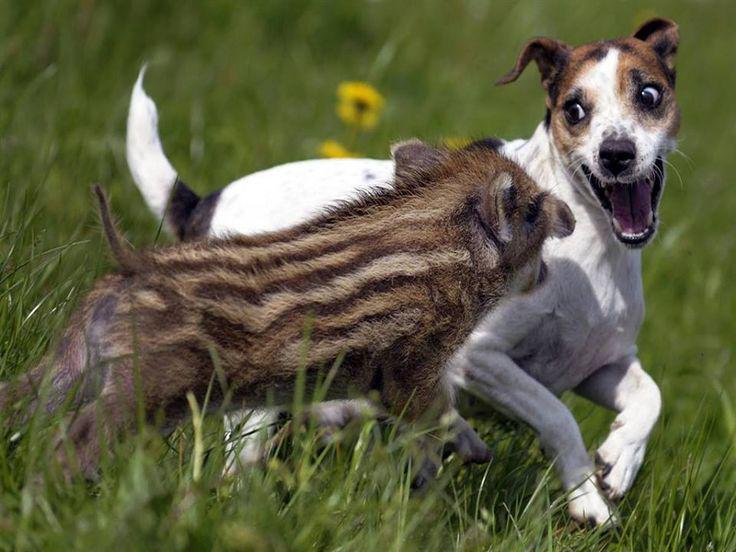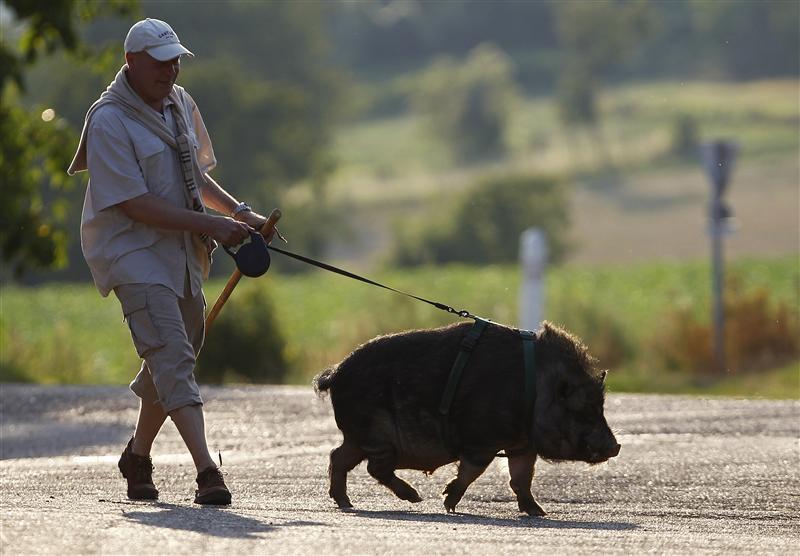The first image is the image on the left, the second image is the image on the right. Given the left and right images, does the statement "One pig is moving across the pavement." hold true? Answer yes or no. Yes. The first image is the image on the left, the second image is the image on the right. Examine the images to the left and right. Is the description "An image shows a striped baby wild pig standing parallel to a dog with its mouth open wide." accurate? Answer yes or no. Yes. 